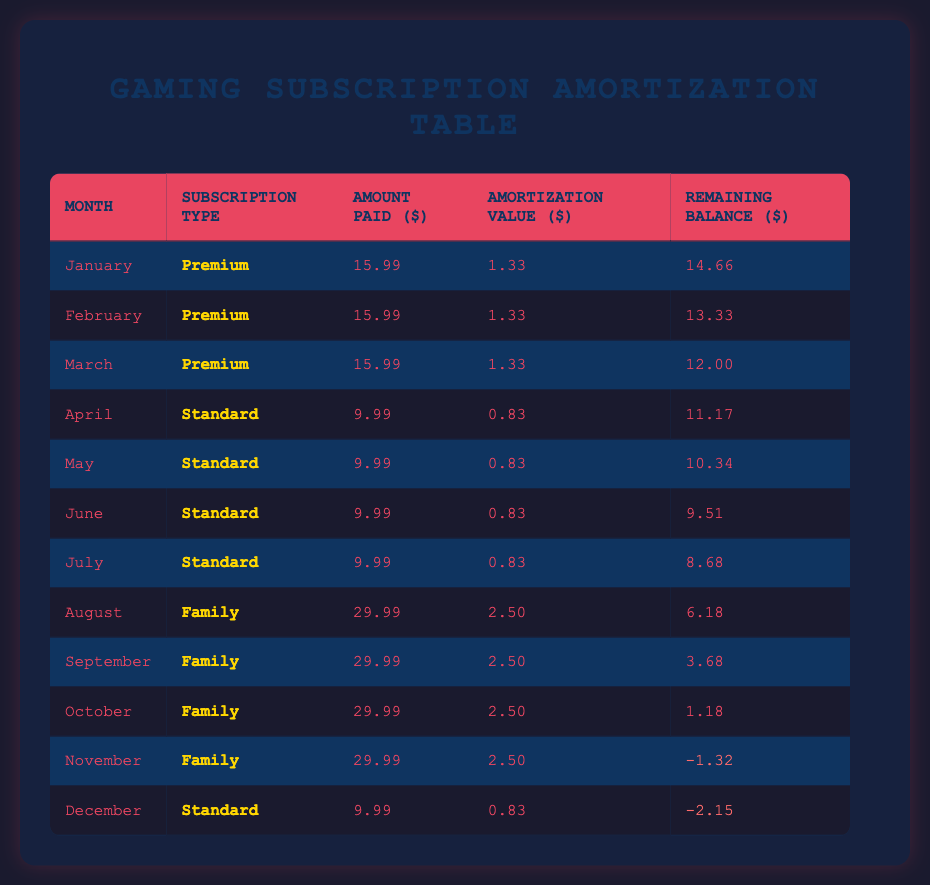What is the total amount paid by players for "Premium" subscriptions over the first three months? In the first three months (January, February, March), the amount paid for "Premium" subscriptions is $15.99 each month. Therefore, the total amount is 15.99 + 15.99 + 15.99 = $47.97.
Answer: 47.97 In which month does the "Family" subscription plan start? The "Family" subscription plan starts in August, as indicated in the table where the first occurrence of this type is listed.
Answer: August What is the amortization value for the "Standard" subscription in June? The amortization value for the "Standard" subscription in June, as indicated in the June row of the table, is $0.83.
Answer: 0.83 Did any subscription type have a negative remaining balance by the end of the year? Yes, both the "Family" subscription in November and the "Standard" subscription in December had negative remaining balances. The balances were -1.32 for November and -2.15 for December.
Answer: Yes How much more did players pay for the "Family" subscription compared to the "Standard" subscription in the months they overlap? In the months of overlap (August, September, October, November, December), the "Family" subscription is $29.99 while the "Standard" subscription is $9.99. The difference is 29.99 - 9.99 = 20.00. Over the 5 months, players paid (29.99 - 9.99) * 5 = 100.00 more for the "Family" subscription than the "Standard" subscription.
Answer: 100.00 What is the remaining balance at the end of the year? The remaining balance at the end of December, as indicated in the table, is -2.15.
Answer: -2.15 Which month and subscription type had the highest amount paid, and what was that amount? The month and subscription type with the highest amount paid is August for the "Family" subscription, which was $29.99.
Answer: August, Family, 29.99 Was there any month in which the amortization value was above $2? No, the highest amortization value in the table is $2.50, which occurs for the "Family" subscription in August, September, October, and November, but no month has a value exceeding this amount.
Answer: No What was the total amount paid for subscriptions in the first half of the year? The total amount paid from January to June: January, February, March - $15.99 each; April, May, June - $9.99 each. Therefore, total = 15.99 * 3 + 9.99 * 3 = 47.97 + 29.97 = 77.94.
Answer: 77.94 